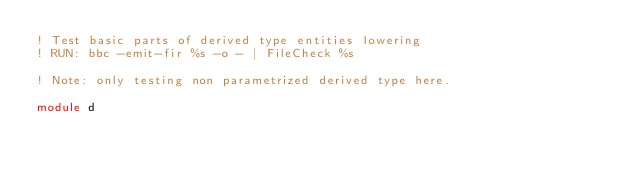Convert code to text. <code><loc_0><loc_0><loc_500><loc_500><_FORTRAN_>! Test basic parts of derived type entities lowering
! RUN: bbc -emit-fir %s -o - | FileCheck %s

! Note: only testing non parametrized derived type here.

module d</code> 